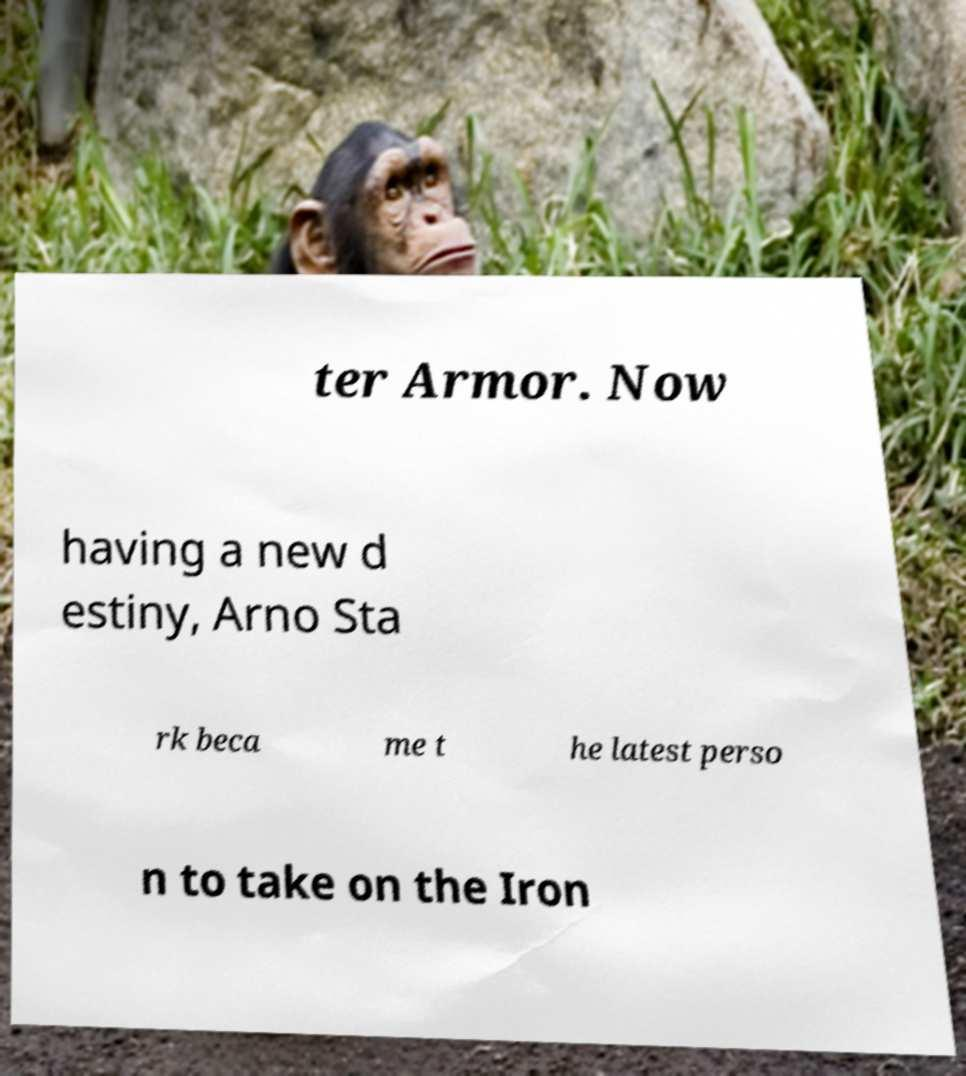What messages or text are displayed in this image? I need them in a readable, typed format. ter Armor. Now having a new d estiny, Arno Sta rk beca me t he latest perso n to take on the Iron 